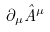Convert formula to latex. <formula><loc_0><loc_0><loc_500><loc_500>\partial _ { \mu } \hat { A } ^ { \mu }</formula> 